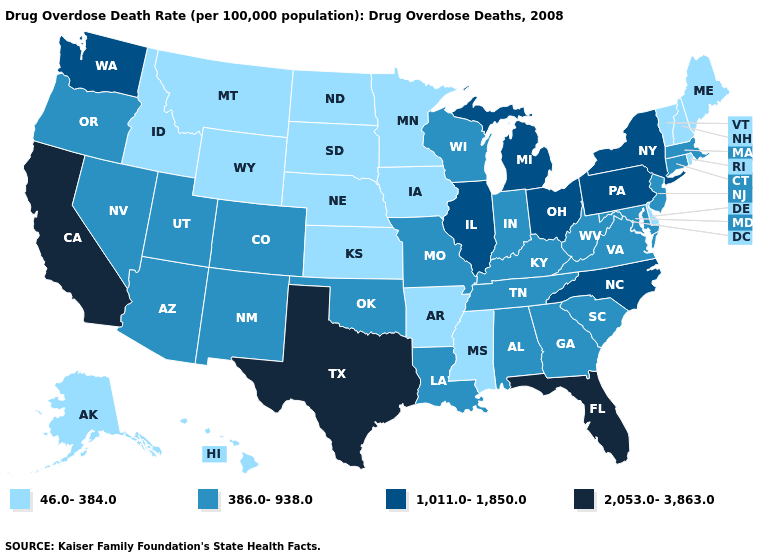What is the value of Vermont?
Concise answer only. 46.0-384.0. Name the states that have a value in the range 386.0-938.0?
Give a very brief answer. Alabama, Arizona, Colorado, Connecticut, Georgia, Indiana, Kentucky, Louisiana, Maryland, Massachusetts, Missouri, Nevada, New Jersey, New Mexico, Oklahoma, Oregon, South Carolina, Tennessee, Utah, Virginia, West Virginia, Wisconsin. Is the legend a continuous bar?
Write a very short answer. No. Does the first symbol in the legend represent the smallest category?
Write a very short answer. Yes. Name the states that have a value in the range 46.0-384.0?
Give a very brief answer. Alaska, Arkansas, Delaware, Hawaii, Idaho, Iowa, Kansas, Maine, Minnesota, Mississippi, Montana, Nebraska, New Hampshire, North Dakota, Rhode Island, South Dakota, Vermont, Wyoming. What is the value of Louisiana?
Quick response, please. 386.0-938.0. Is the legend a continuous bar?
Quick response, please. No. What is the lowest value in states that border Delaware?
Give a very brief answer. 386.0-938.0. Does the map have missing data?
Keep it brief. No. What is the lowest value in the USA?
Give a very brief answer. 46.0-384.0. Among the states that border Vermont , does New York have the lowest value?
Be succinct. No. What is the lowest value in the USA?
Give a very brief answer. 46.0-384.0. Does the first symbol in the legend represent the smallest category?
Write a very short answer. Yes. Does the map have missing data?
Quick response, please. No. 